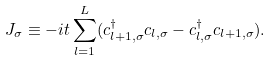<formula> <loc_0><loc_0><loc_500><loc_500>J _ { \sigma } \equiv - i t \sum _ { l = 1 } ^ { L } ( c _ { l + 1 , \sigma } ^ { \dag } c _ { l , \sigma } - c _ { l , \sigma } ^ { \dag } c _ { l + 1 , \sigma } ) .</formula> 